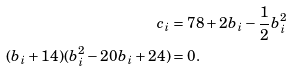Convert formula to latex. <formula><loc_0><loc_0><loc_500><loc_500>c _ { i } & = 7 8 + 2 b _ { i } - \frac { 1 } { 2 } b _ { i } ^ { 2 } \\ ( b _ { i } + 1 4 ) ( b _ { i } ^ { 2 } - 2 0 b _ { i } + 2 4 ) & = 0 .</formula> 